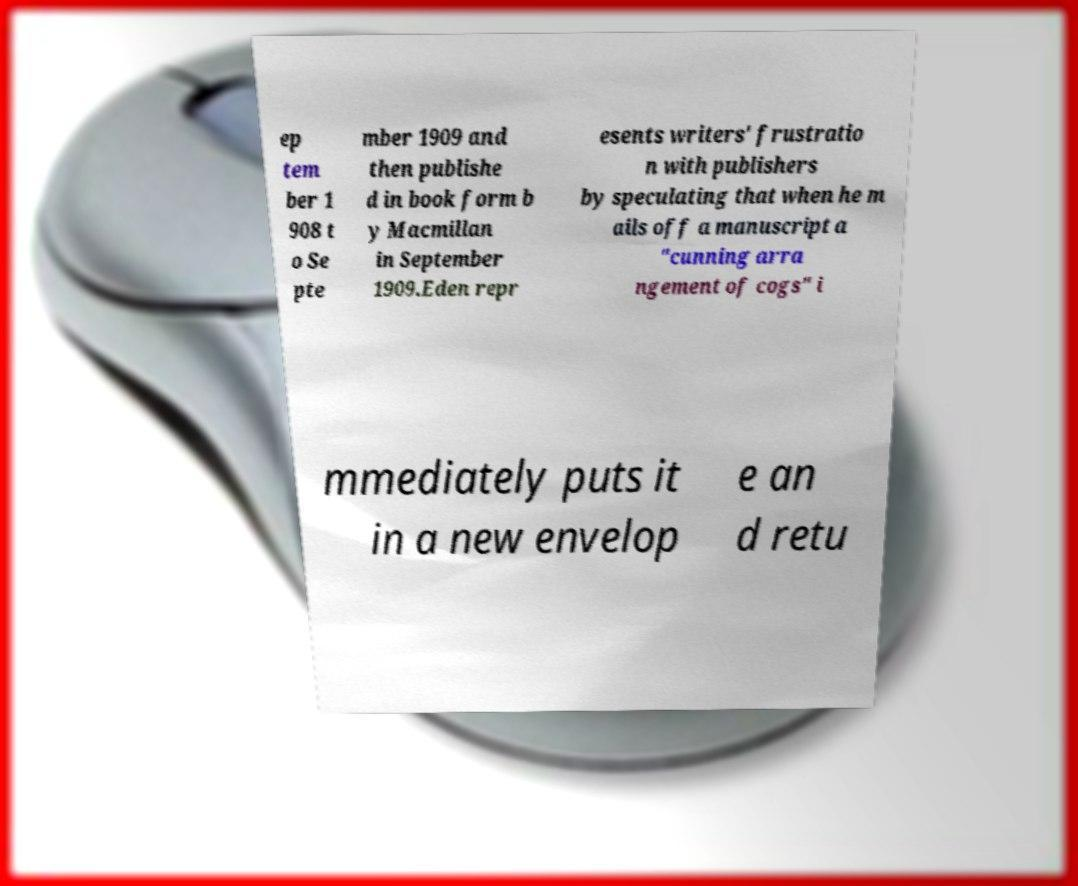There's text embedded in this image that I need extracted. Can you transcribe it verbatim? ep tem ber 1 908 t o Se pte mber 1909 and then publishe d in book form b y Macmillan in September 1909.Eden repr esents writers' frustratio n with publishers by speculating that when he m ails off a manuscript a "cunning arra ngement of cogs" i mmediately puts it in a new envelop e an d retu 